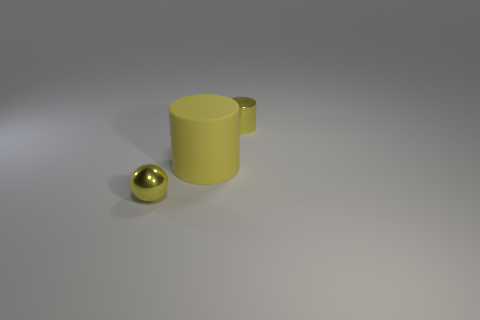Add 3 gray cylinders. How many objects exist? 6 Subtract all spheres. How many objects are left? 2 Subtract 0 blue cubes. How many objects are left? 3 Subtract all tiny cyan metal cylinders. Subtract all rubber objects. How many objects are left? 2 Add 1 big things. How many big things are left? 2 Add 1 red things. How many red things exist? 1 